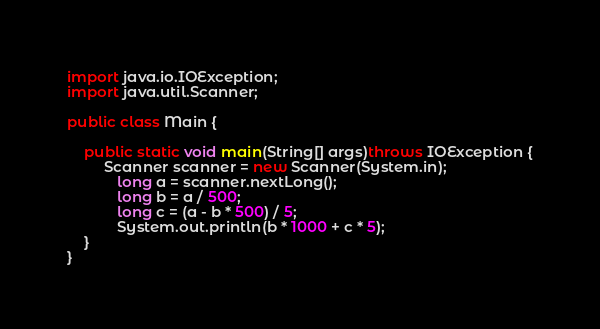<code> <loc_0><loc_0><loc_500><loc_500><_Java_>import java.io.IOException;
import java.util.Scanner;

public class Main {

	public static void main(String[] args)throws IOException {
		 Scanner scanner = new Scanner(System.in);
	        long a = scanner.nextLong();
	        long b = a / 500;
	        long c = (a - b * 500) / 5;
	        System.out.println(b * 1000 + c * 5);
	}
}
</code> 